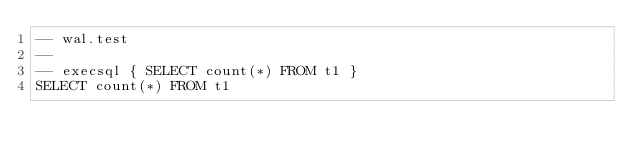Convert code to text. <code><loc_0><loc_0><loc_500><loc_500><_SQL_>-- wal.test
-- 
-- execsql { SELECT count(*) FROM t1 }
SELECT count(*) FROM t1</code> 